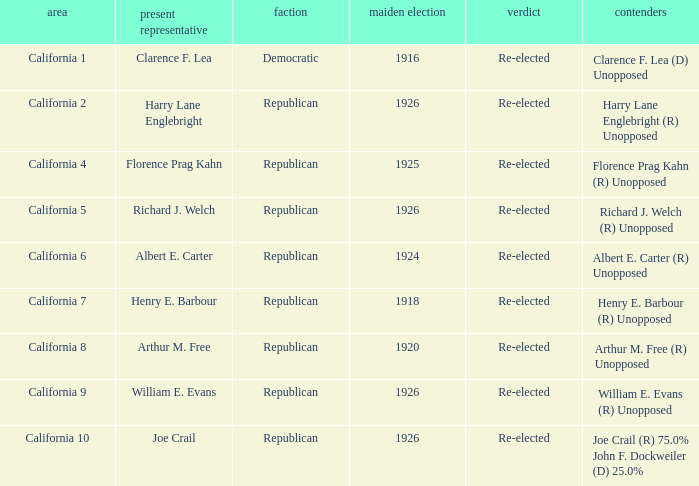What's the party with incumbent being william e. evans Republican. 